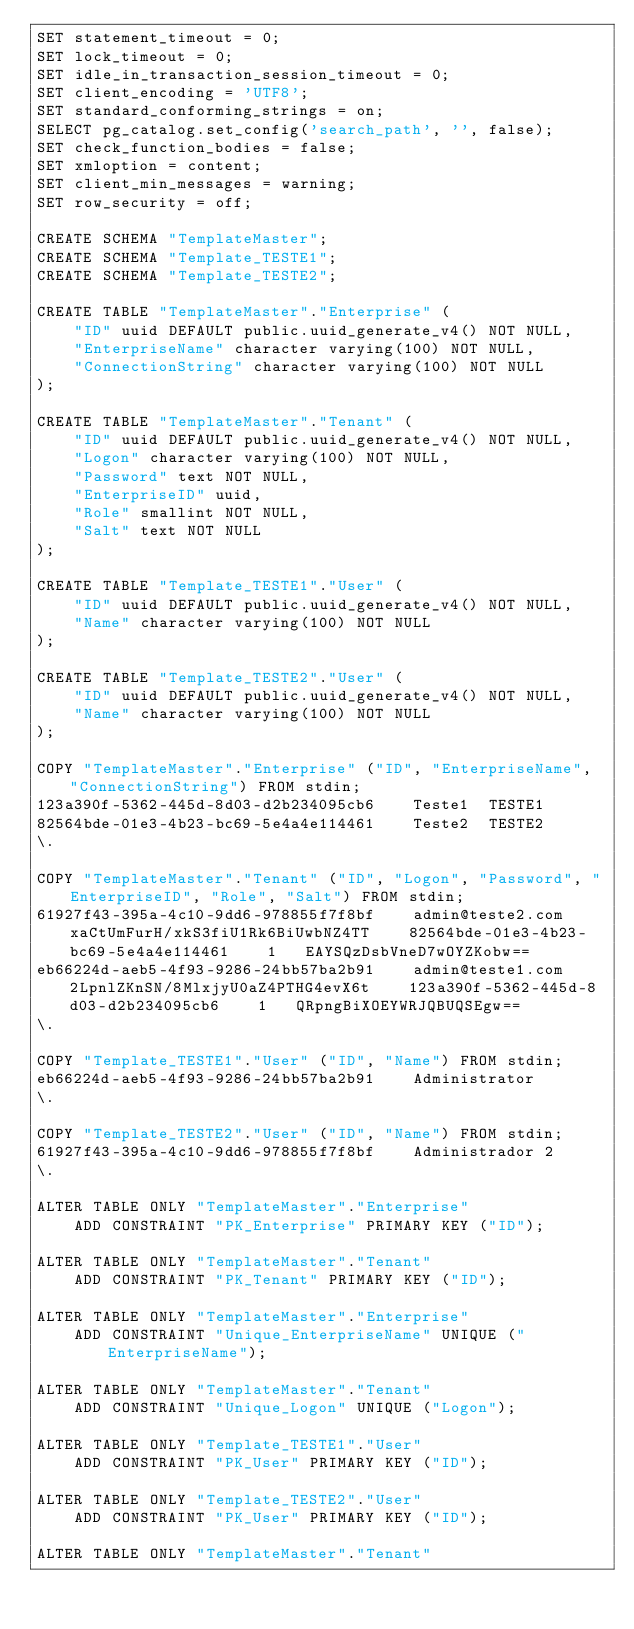<code> <loc_0><loc_0><loc_500><loc_500><_SQL_>SET statement_timeout = 0;
SET lock_timeout = 0;
SET idle_in_transaction_session_timeout = 0;
SET client_encoding = 'UTF8';
SET standard_conforming_strings = on;
SELECT pg_catalog.set_config('search_path', '', false);
SET check_function_bodies = false;
SET xmloption = content;
SET client_min_messages = warning;
SET row_security = off;

CREATE SCHEMA "TemplateMaster";
CREATE SCHEMA "Template_TESTE1";
CREATE SCHEMA "Template_TESTE2";

CREATE TABLE "TemplateMaster"."Enterprise" (
    "ID" uuid DEFAULT public.uuid_generate_v4() NOT NULL,
    "EnterpriseName" character varying(100) NOT NULL,
    "ConnectionString" character varying(100) NOT NULL
);

CREATE TABLE "TemplateMaster"."Tenant" (
    "ID" uuid DEFAULT public.uuid_generate_v4() NOT NULL,
    "Logon" character varying(100) NOT NULL,
    "Password" text NOT NULL,
    "EnterpriseID" uuid,
    "Role" smallint NOT NULL,
    "Salt" text NOT NULL
);

CREATE TABLE "Template_TESTE1"."User" (
    "ID" uuid DEFAULT public.uuid_generate_v4() NOT NULL,
    "Name" character varying(100) NOT NULL
);

CREATE TABLE "Template_TESTE2"."User" (
    "ID" uuid DEFAULT public.uuid_generate_v4() NOT NULL,
    "Name" character varying(100) NOT NULL
);

COPY "TemplateMaster"."Enterprise" ("ID", "EnterpriseName", "ConnectionString") FROM stdin;
123a390f-5362-445d-8d03-d2b234095cb6	Teste1	TESTE1
82564bde-01e3-4b23-bc69-5e4a4e114461	Teste2	TESTE2
\.

COPY "TemplateMaster"."Tenant" ("ID", "Logon", "Password", "EnterpriseID", "Role", "Salt") FROM stdin;
61927f43-395a-4c10-9dd6-978855f7f8bf	admin@teste2.com	xaCtUmFurH/xkS3fiU1Rk6BiUwbNZ4TT	82564bde-01e3-4b23-bc69-5e4a4e114461	1	EAYSQzDsbVneD7wOYZKobw==
eb66224d-aeb5-4f93-9286-24bb57ba2b91	admin@teste1.com	2LpnlZKnSN/8MlxjyU0aZ4PTHG4evX6t	123a390f-5362-445d-8d03-d2b234095cb6	1	QRpngBiXOEYWRJQBUQSEgw==
\.

COPY "Template_TESTE1"."User" ("ID", "Name") FROM stdin;
eb66224d-aeb5-4f93-9286-24bb57ba2b91	Administrator
\.

COPY "Template_TESTE2"."User" ("ID", "Name") FROM stdin;
61927f43-395a-4c10-9dd6-978855f7f8bf	Administrador 2
\.

ALTER TABLE ONLY "TemplateMaster"."Enterprise"
    ADD CONSTRAINT "PK_Enterprise" PRIMARY KEY ("ID");

ALTER TABLE ONLY "TemplateMaster"."Tenant"
    ADD CONSTRAINT "PK_Tenant" PRIMARY KEY ("ID");

ALTER TABLE ONLY "TemplateMaster"."Enterprise"
    ADD CONSTRAINT "Unique_EnterpriseName" UNIQUE ("EnterpriseName");

ALTER TABLE ONLY "TemplateMaster"."Tenant"
    ADD CONSTRAINT "Unique_Logon" UNIQUE ("Logon");

ALTER TABLE ONLY "Template_TESTE1"."User"
    ADD CONSTRAINT "PK_User" PRIMARY KEY ("ID");

ALTER TABLE ONLY "Template_TESTE2"."User"
    ADD CONSTRAINT "PK_User" PRIMARY KEY ("ID");

ALTER TABLE ONLY "TemplateMaster"."Tenant"</code> 